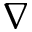Convert formula to latex. <formula><loc_0><loc_0><loc_500><loc_500>\nabla</formula> 